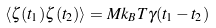<formula> <loc_0><loc_0><loc_500><loc_500>\left \langle \zeta ( t _ { 1 } ) \zeta ( t _ { 2 } ) \right \rangle = M k _ { B } T \gamma ( t _ { 1 } - t _ { 2 } )</formula> 